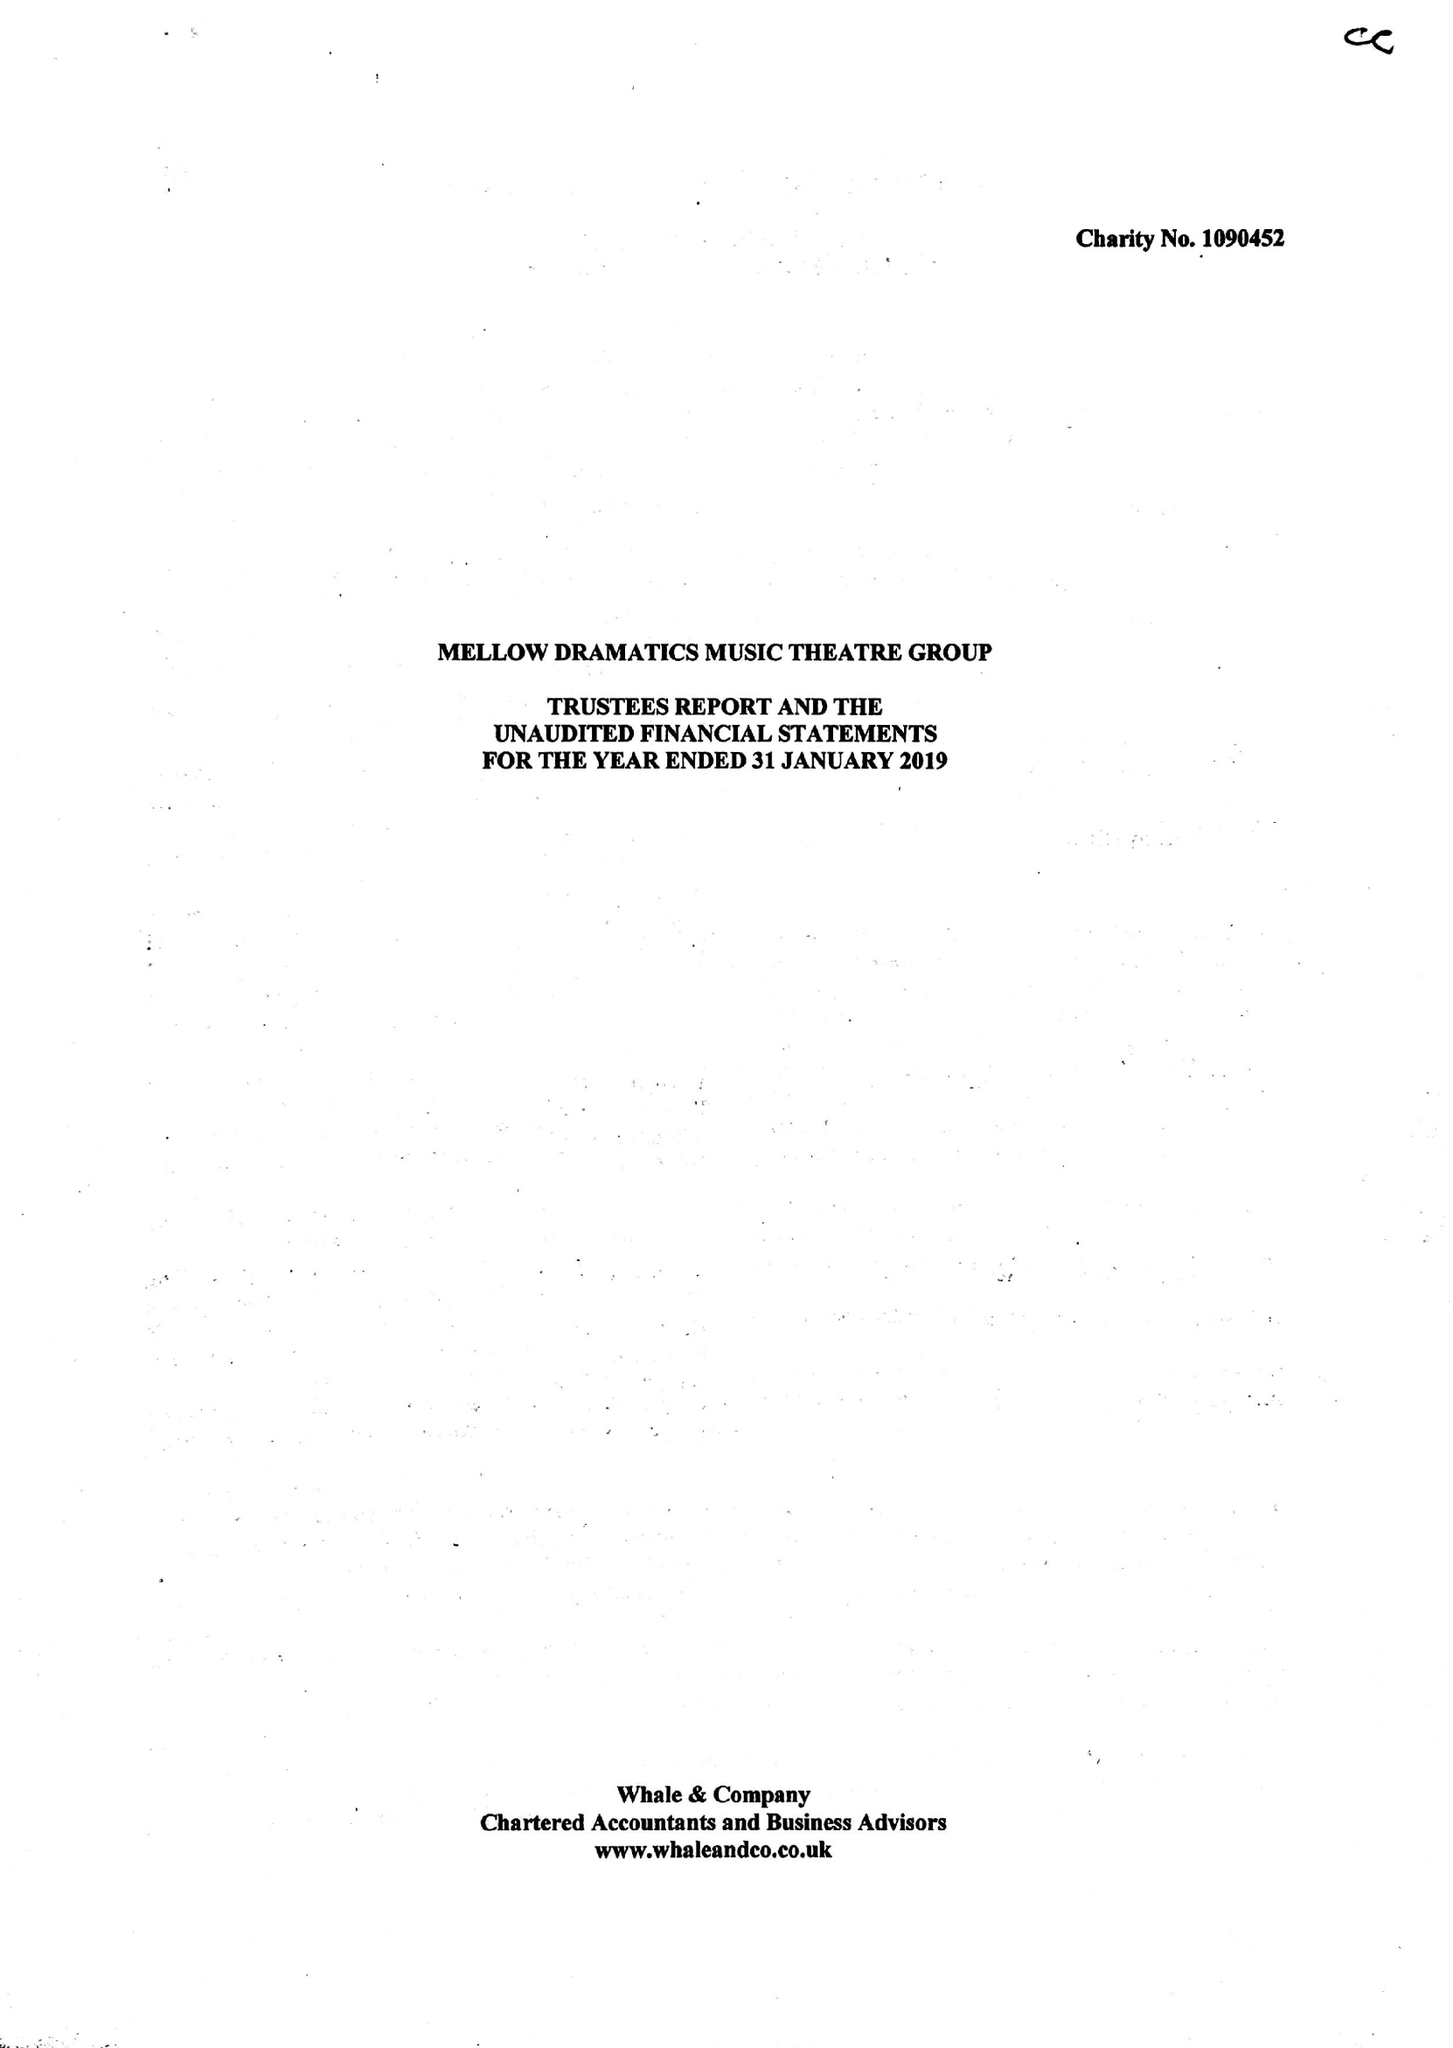What is the value for the address__street_line?
Answer the question using a single word or phrase. 9 THORPE CLOSE 